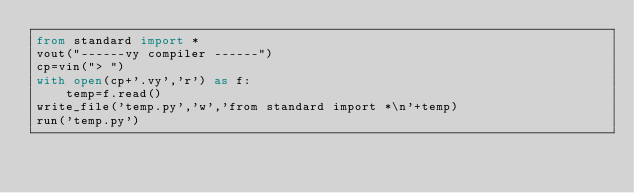<code> <loc_0><loc_0><loc_500><loc_500><_Python_>from standard import *
vout("------vy compiler ------")
cp=vin("> ")
with open(cp+'.vy','r') as f:
    temp=f.read()
write_file('temp.py','w','from standard import *\n'+temp)
run('temp.py')
</code> 